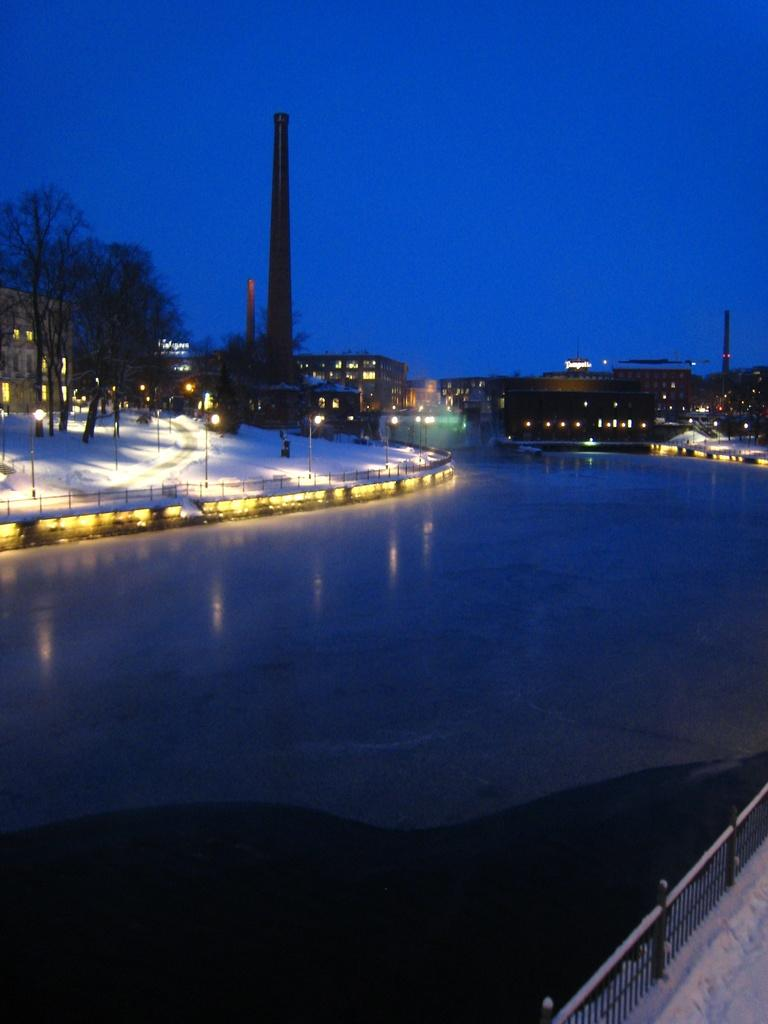What type of structures can be seen in the image? There are buildings in the image. What are the light poles used for in the image? The light poles provide illumination in the image. What type of vegetation is present in the image? There are trees in the image. What type of barrier can be seen in the image? There is fencing in the image. What natural element is visible in the image? Water is visible in the image. What is the color of the sky in the image? The sky is blue in color. How many cows are grazing in the water in the image? There are no cows present in the image. Can you describe the person walking along the fencing in the image? There is no person present in the image. 